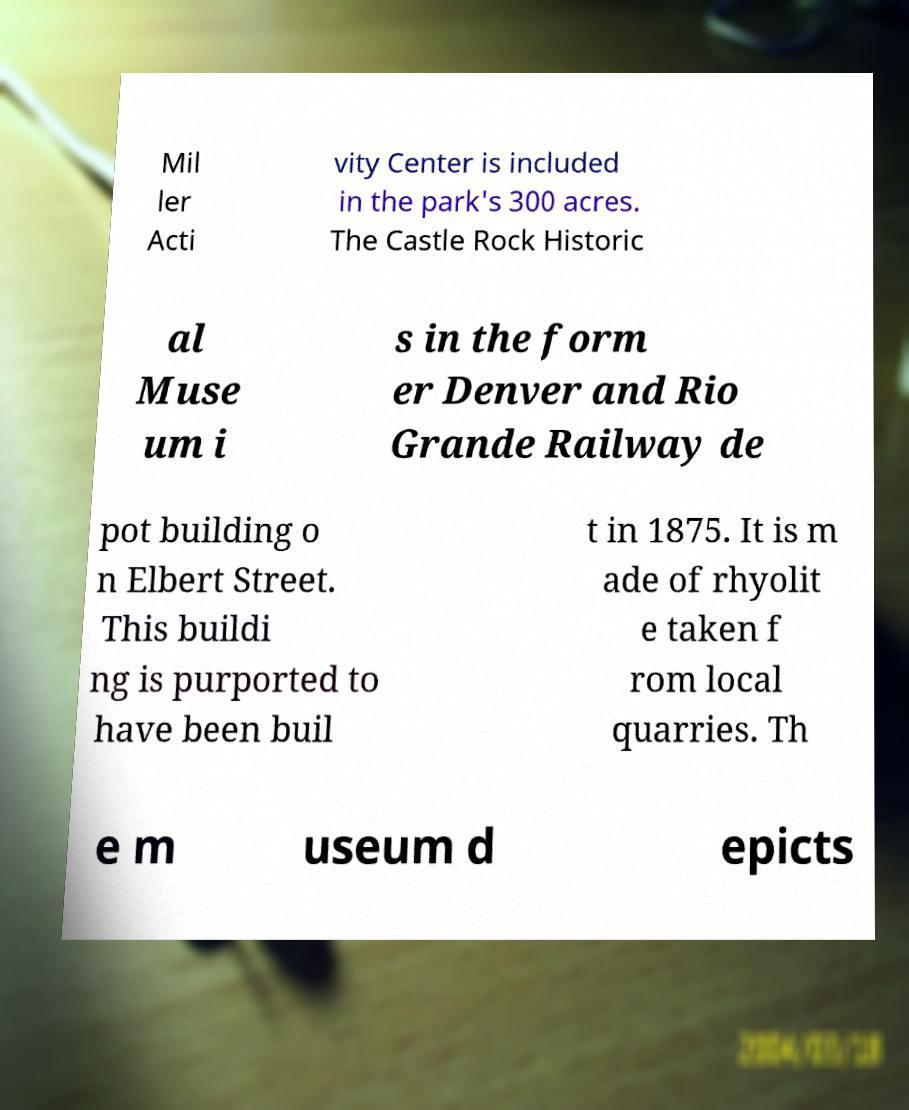Can you accurately transcribe the text from the provided image for me? Mil ler Acti vity Center is included in the park's 300 acres. The Castle Rock Historic al Muse um i s in the form er Denver and Rio Grande Railway de pot building o n Elbert Street. This buildi ng is purported to have been buil t in 1875. It is m ade of rhyolit e taken f rom local quarries. Th e m useum d epicts 